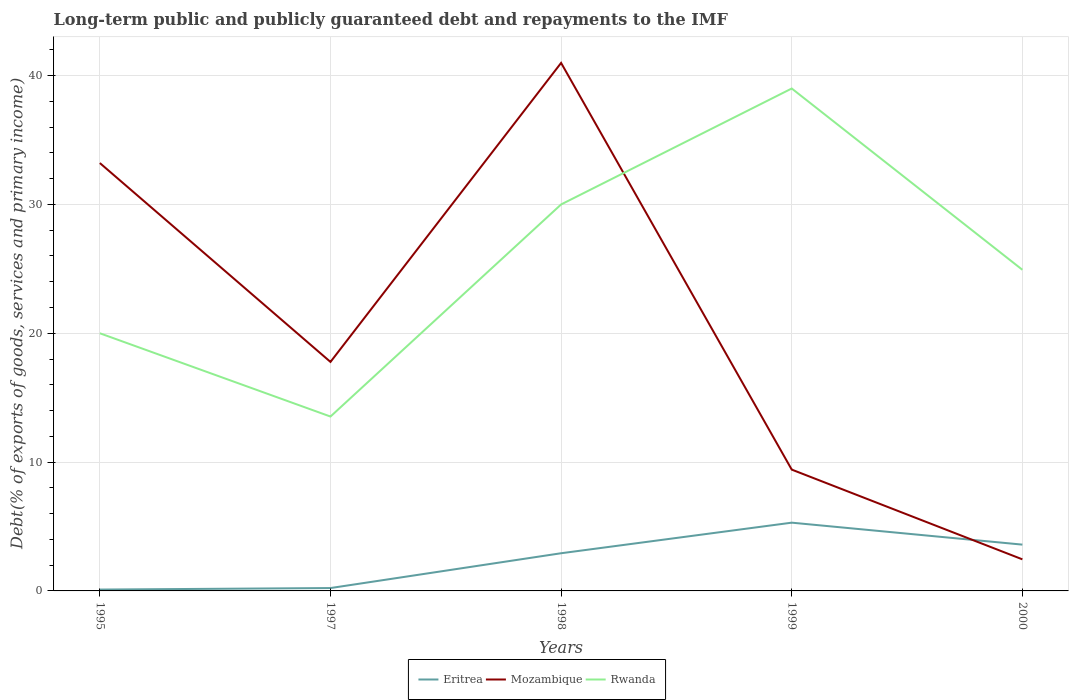How many different coloured lines are there?
Ensure brevity in your answer.  3. Does the line corresponding to Eritrea intersect with the line corresponding to Rwanda?
Keep it short and to the point. No. Across all years, what is the maximum debt and repayments in Rwanda?
Provide a short and direct response. 13.54. In which year was the debt and repayments in Eritrea maximum?
Your answer should be compact. 1995. What is the total debt and repayments in Eritrea in the graph?
Provide a short and direct response. -2.37. What is the difference between the highest and the second highest debt and repayments in Rwanda?
Give a very brief answer. 25.46. Is the debt and repayments in Eritrea strictly greater than the debt and repayments in Rwanda over the years?
Your answer should be very brief. Yes. How many years are there in the graph?
Make the answer very short. 5. What is the difference between two consecutive major ticks on the Y-axis?
Offer a very short reply. 10. Does the graph contain any zero values?
Provide a succinct answer. No. Does the graph contain grids?
Offer a terse response. Yes. Where does the legend appear in the graph?
Your answer should be very brief. Bottom center. How many legend labels are there?
Your answer should be very brief. 3. What is the title of the graph?
Make the answer very short. Long-term public and publicly guaranteed debt and repayments to the IMF. Does "Romania" appear as one of the legend labels in the graph?
Give a very brief answer. No. What is the label or title of the Y-axis?
Provide a succinct answer. Debt(% of exports of goods, services and primary income). What is the Debt(% of exports of goods, services and primary income) of Eritrea in 1995?
Your answer should be very brief. 0.11. What is the Debt(% of exports of goods, services and primary income) in Mozambique in 1995?
Keep it short and to the point. 33.21. What is the Debt(% of exports of goods, services and primary income) in Rwanda in 1995?
Your response must be concise. 20. What is the Debt(% of exports of goods, services and primary income) of Eritrea in 1997?
Make the answer very short. 0.22. What is the Debt(% of exports of goods, services and primary income) in Mozambique in 1997?
Offer a very short reply. 17.78. What is the Debt(% of exports of goods, services and primary income) of Rwanda in 1997?
Provide a short and direct response. 13.54. What is the Debt(% of exports of goods, services and primary income) of Eritrea in 1998?
Your answer should be very brief. 2.92. What is the Debt(% of exports of goods, services and primary income) in Mozambique in 1998?
Provide a short and direct response. 40.99. What is the Debt(% of exports of goods, services and primary income) of Eritrea in 1999?
Your answer should be compact. 5.3. What is the Debt(% of exports of goods, services and primary income) of Mozambique in 1999?
Provide a short and direct response. 9.42. What is the Debt(% of exports of goods, services and primary income) of Eritrea in 2000?
Provide a short and direct response. 3.59. What is the Debt(% of exports of goods, services and primary income) of Mozambique in 2000?
Your answer should be very brief. 2.45. What is the Debt(% of exports of goods, services and primary income) in Rwanda in 2000?
Make the answer very short. 24.93. Across all years, what is the maximum Debt(% of exports of goods, services and primary income) in Eritrea?
Provide a short and direct response. 5.3. Across all years, what is the maximum Debt(% of exports of goods, services and primary income) in Mozambique?
Your answer should be compact. 40.99. Across all years, what is the minimum Debt(% of exports of goods, services and primary income) in Eritrea?
Keep it short and to the point. 0.11. Across all years, what is the minimum Debt(% of exports of goods, services and primary income) in Mozambique?
Your answer should be compact. 2.45. Across all years, what is the minimum Debt(% of exports of goods, services and primary income) of Rwanda?
Offer a terse response. 13.54. What is the total Debt(% of exports of goods, services and primary income) of Eritrea in the graph?
Give a very brief answer. 12.14. What is the total Debt(% of exports of goods, services and primary income) of Mozambique in the graph?
Your answer should be very brief. 103.84. What is the total Debt(% of exports of goods, services and primary income) in Rwanda in the graph?
Your answer should be very brief. 127.47. What is the difference between the Debt(% of exports of goods, services and primary income) of Eritrea in 1995 and that in 1997?
Give a very brief answer. -0.12. What is the difference between the Debt(% of exports of goods, services and primary income) of Mozambique in 1995 and that in 1997?
Make the answer very short. 15.44. What is the difference between the Debt(% of exports of goods, services and primary income) of Rwanda in 1995 and that in 1997?
Give a very brief answer. 6.46. What is the difference between the Debt(% of exports of goods, services and primary income) of Eritrea in 1995 and that in 1998?
Provide a short and direct response. -2.82. What is the difference between the Debt(% of exports of goods, services and primary income) in Mozambique in 1995 and that in 1998?
Offer a very short reply. -7.77. What is the difference between the Debt(% of exports of goods, services and primary income) of Rwanda in 1995 and that in 1998?
Your answer should be very brief. -10. What is the difference between the Debt(% of exports of goods, services and primary income) in Eritrea in 1995 and that in 1999?
Keep it short and to the point. -5.19. What is the difference between the Debt(% of exports of goods, services and primary income) of Mozambique in 1995 and that in 1999?
Offer a very short reply. 23.8. What is the difference between the Debt(% of exports of goods, services and primary income) in Rwanda in 1995 and that in 1999?
Offer a terse response. -19. What is the difference between the Debt(% of exports of goods, services and primary income) of Eritrea in 1995 and that in 2000?
Provide a short and direct response. -3.49. What is the difference between the Debt(% of exports of goods, services and primary income) in Mozambique in 1995 and that in 2000?
Give a very brief answer. 30.76. What is the difference between the Debt(% of exports of goods, services and primary income) of Rwanda in 1995 and that in 2000?
Ensure brevity in your answer.  -4.93. What is the difference between the Debt(% of exports of goods, services and primary income) in Eritrea in 1997 and that in 1998?
Your response must be concise. -2.7. What is the difference between the Debt(% of exports of goods, services and primary income) in Mozambique in 1997 and that in 1998?
Offer a terse response. -23.21. What is the difference between the Debt(% of exports of goods, services and primary income) of Rwanda in 1997 and that in 1998?
Offer a terse response. -16.46. What is the difference between the Debt(% of exports of goods, services and primary income) of Eritrea in 1997 and that in 1999?
Provide a short and direct response. -5.08. What is the difference between the Debt(% of exports of goods, services and primary income) in Mozambique in 1997 and that in 1999?
Offer a terse response. 8.36. What is the difference between the Debt(% of exports of goods, services and primary income) in Rwanda in 1997 and that in 1999?
Make the answer very short. -25.46. What is the difference between the Debt(% of exports of goods, services and primary income) of Eritrea in 1997 and that in 2000?
Provide a succinct answer. -3.37. What is the difference between the Debt(% of exports of goods, services and primary income) in Mozambique in 1997 and that in 2000?
Your answer should be very brief. 15.32. What is the difference between the Debt(% of exports of goods, services and primary income) of Rwanda in 1997 and that in 2000?
Make the answer very short. -11.39. What is the difference between the Debt(% of exports of goods, services and primary income) in Eritrea in 1998 and that in 1999?
Make the answer very short. -2.37. What is the difference between the Debt(% of exports of goods, services and primary income) in Mozambique in 1998 and that in 1999?
Make the answer very short. 31.57. What is the difference between the Debt(% of exports of goods, services and primary income) in Rwanda in 1998 and that in 1999?
Your answer should be very brief. -9. What is the difference between the Debt(% of exports of goods, services and primary income) in Eritrea in 1998 and that in 2000?
Your response must be concise. -0.67. What is the difference between the Debt(% of exports of goods, services and primary income) of Mozambique in 1998 and that in 2000?
Your answer should be very brief. 38.53. What is the difference between the Debt(% of exports of goods, services and primary income) in Rwanda in 1998 and that in 2000?
Provide a short and direct response. 5.07. What is the difference between the Debt(% of exports of goods, services and primary income) of Eritrea in 1999 and that in 2000?
Your answer should be compact. 1.7. What is the difference between the Debt(% of exports of goods, services and primary income) of Mozambique in 1999 and that in 2000?
Provide a short and direct response. 6.96. What is the difference between the Debt(% of exports of goods, services and primary income) of Rwanda in 1999 and that in 2000?
Keep it short and to the point. 14.07. What is the difference between the Debt(% of exports of goods, services and primary income) in Eritrea in 1995 and the Debt(% of exports of goods, services and primary income) in Mozambique in 1997?
Provide a succinct answer. -17.67. What is the difference between the Debt(% of exports of goods, services and primary income) in Eritrea in 1995 and the Debt(% of exports of goods, services and primary income) in Rwanda in 1997?
Ensure brevity in your answer.  -13.43. What is the difference between the Debt(% of exports of goods, services and primary income) in Mozambique in 1995 and the Debt(% of exports of goods, services and primary income) in Rwanda in 1997?
Make the answer very short. 19.68. What is the difference between the Debt(% of exports of goods, services and primary income) of Eritrea in 1995 and the Debt(% of exports of goods, services and primary income) of Mozambique in 1998?
Make the answer very short. -40.88. What is the difference between the Debt(% of exports of goods, services and primary income) in Eritrea in 1995 and the Debt(% of exports of goods, services and primary income) in Rwanda in 1998?
Provide a short and direct response. -29.89. What is the difference between the Debt(% of exports of goods, services and primary income) in Mozambique in 1995 and the Debt(% of exports of goods, services and primary income) in Rwanda in 1998?
Keep it short and to the point. 3.21. What is the difference between the Debt(% of exports of goods, services and primary income) in Eritrea in 1995 and the Debt(% of exports of goods, services and primary income) in Mozambique in 1999?
Provide a succinct answer. -9.31. What is the difference between the Debt(% of exports of goods, services and primary income) of Eritrea in 1995 and the Debt(% of exports of goods, services and primary income) of Rwanda in 1999?
Make the answer very short. -38.89. What is the difference between the Debt(% of exports of goods, services and primary income) in Mozambique in 1995 and the Debt(% of exports of goods, services and primary income) in Rwanda in 1999?
Give a very brief answer. -5.79. What is the difference between the Debt(% of exports of goods, services and primary income) in Eritrea in 1995 and the Debt(% of exports of goods, services and primary income) in Mozambique in 2000?
Give a very brief answer. -2.35. What is the difference between the Debt(% of exports of goods, services and primary income) in Eritrea in 1995 and the Debt(% of exports of goods, services and primary income) in Rwanda in 2000?
Make the answer very short. -24.82. What is the difference between the Debt(% of exports of goods, services and primary income) in Mozambique in 1995 and the Debt(% of exports of goods, services and primary income) in Rwanda in 2000?
Provide a short and direct response. 8.28. What is the difference between the Debt(% of exports of goods, services and primary income) of Eritrea in 1997 and the Debt(% of exports of goods, services and primary income) of Mozambique in 1998?
Make the answer very short. -40.76. What is the difference between the Debt(% of exports of goods, services and primary income) of Eritrea in 1997 and the Debt(% of exports of goods, services and primary income) of Rwanda in 1998?
Your response must be concise. -29.78. What is the difference between the Debt(% of exports of goods, services and primary income) in Mozambique in 1997 and the Debt(% of exports of goods, services and primary income) in Rwanda in 1998?
Keep it short and to the point. -12.22. What is the difference between the Debt(% of exports of goods, services and primary income) in Eritrea in 1997 and the Debt(% of exports of goods, services and primary income) in Mozambique in 1999?
Provide a succinct answer. -9.19. What is the difference between the Debt(% of exports of goods, services and primary income) of Eritrea in 1997 and the Debt(% of exports of goods, services and primary income) of Rwanda in 1999?
Make the answer very short. -38.78. What is the difference between the Debt(% of exports of goods, services and primary income) of Mozambique in 1997 and the Debt(% of exports of goods, services and primary income) of Rwanda in 1999?
Offer a very short reply. -21.22. What is the difference between the Debt(% of exports of goods, services and primary income) in Eritrea in 1997 and the Debt(% of exports of goods, services and primary income) in Mozambique in 2000?
Provide a short and direct response. -2.23. What is the difference between the Debt(% of exports of goods, services and primary income) of Eritrea in 1997 and the Debt(% of exports of goods, services and primary income) of Rwanda in 2000?
Your response must be concise. -24.71. What is the difference between the Debt(% of exports of goods, services and primary income) in Mozambique in 1997 and the Debt(% of exports of goods, services and primary income) in Rwanda in 2000?
Give a very brief answer. -7.15. What is the difference between the Debt(% of exports of goods, services and primary income) of Eritrea in 1998 and the Debt(% of exports of goods, services and primary income) of Mozambique in 1999?
Provide a short and direct response. -6.49. What is the difference between the Debt(% of exports of goods, services and primary income) of Eritrea in 1998 and the Debt(% of exports of goods, services and primary income) of Rwanda in 1999?
Provide a succinct answer. -36.08. What is the difference between the Debt(% of exports of goods, services and primary income) in Mozambique in 1998 and the Debt(% of exports of goods, services and primary income) in Rwanda in 1999?
Offer a very short reply. 1.99. What is the difference between the Debt(% of exports of goods, services and primary income) of Eritrea in 1998 and the Debt(% of exports of goods, services and primary income) of Mozambique in 2000?
Provide a succinct answer. 0.47. What is the difference between the Debt(% of exports of goods, services and primary income) of Eritrea in 1998 and the Debt(% of exports of goods, services and primary income) of Rwanda in 2000?
Ensure brevity in your answer.  -22. What is the difference between the Debt(% of exports of goods, services and primary income) of Mozambique in 1998 and the Debt(% of exports of goods, services and primary income) of Rwanda in 2000?
Keep it short and to the point. 16.06. What is the difference between the Debt(% of exports of goods, services and primary income) in Eritrea in 1999 and the Debt(% of exports of goods, services and primary income) in Mozambique in 2000?
Ensure brevity in your answer.  2.85. What is the difference between the Debt(% of exports of goods, services and primary income) of Eritrea in 1999 and the Debt(% of exports of goods, services and primary income) of Rwanda in 2000?
Ensure brevity in your answer.  -19.63. What is the difference between the Debt(% of exports of goods, services and primary income) of Mozambique in 1999 and the Debt(% of exports of goods, services and primary income) of Rwanda in 2000?
Your response must be concise. -15.51. What is the average Debt(% of exports of goods, services and primary income) in Eritrea per year?
Your answer should be very brief. 2.43. What is the average Debt(% of exports of goods, services and primary income) in Mozambique per year?
Your answer should be very brief. 20.77. What is the average Debt(% of exports of goods, services and primary income) in Rwanda per year?
Keep it short and to the point. 25.49. In the year 1995, what is the difference between the Debt(% of exports of goods, services and primary income) of Eritrea and Debt(% of exports of goods, services and primary income) of Mozambique?
Make the answer very short. -33.11. In the year 1995, what is the difference between the Debt(% of exports of goods, services and primary income) of Eritrea and Debt(% of exports of goods, services and primary income) of Rwanda?
Offer a terse response. -19.9. In the year 1995, what is the difference between the Debt(% of exports of goods, services and primary income) of Mozambique and Debt(% of exports of goods, services and primary income) of Rwanda?
Give a very brief answer. 13.21. In the year 1997, what is the difference between the Debt(% of exports of goods, services and primary income) in Eritrea and Debt(% of exports of goods, services and primary income) in Mozambique?
Give a very brief answer. -17.55. In the year 1997, what is the difference between the Debt(% of exports of goods, services and primary income) of Eritrea and Debt(% of exports of goods, services and primary income) of Rwanda?
Your response must be concise. -13.31. In the year 1997, what is the difference between the Debt(% of exports of goods, services and primary income) of Mozambique and Debt(% of exports of goods, services and primary income) of Rwanda?
Make the answer very short. 4.24. In the year 1998, what is the difference between the Debt(% of exports of goods, services and primary income) in Eritrea and Debt(% of exports of goods, services and primary income) in Mozambique?
Provide a short and direct response. -38.06. In the year 1998, what is the difference between the Debt(% of exports of goods, services and primary income) of Eritrea and Debt(% of exports of goods, services and primary income) of Rwanda?
Offer a very short reply. -27.08. In the year 1998, what is the difference between the Debt(% of exports of goods, services and primary income) of Mozambique and Debt(% of exports of goods, services and primary income) of Rwanda?
Your response must be concise. 10.99. In the year 1999, what is the difference between the Debt(% of exports of goods, services and primary income) of Eritrea and Debt(% of exports of goods, services and primary income) of Mozambique?
Keep it short and to the point. -4.12. In the year 1999, what is the difference between the Debt(% of exports of goods, services and primary income) in Eritrea and Debt(% of exports of goods, services and primary income) in Rwanda?
Give a very brief answer. -33.7. In the year 1999, what is the difference between the Debt(% of exports of goods, services and primary income) in Mozambique and Debt(% of exports of goods, services and primary income) in Rwanda?
Offer a very short reply. -29.58. In the year 2000, what is the difference between the Debt(% of exports of goods, services and primary income) in Eritrea and Debt(% of exports of goods, services and primary income) in Mozambique?
Ensure brevity in your answer.  1.14. In the year 2000, what is the difference between the Debt(% of exports of goods, services and primary income) in Eritrea and Debt(% of exports of goods, services and primary income) in Rwanda?
Provide a succinct answer. -21.34. In the year 2000, what is the difference between the Debt(% of exports of goods, services and primary income) of Mozambique and Debt(% of exports of goods, services and primary income) of Rwanda?
Your answer should be very brief. -22.48. What is the ratio of the Debt(% of exports of goods, services and primary income) in Eritrea in 1995 to that in 1997?
Make the answer very short. 0.47. What is the ratio of the Debt(% of exports of goods, services and primary income) in Mozambique in 1995 to that in 1997?
Your response must be concise. 1.87. What is the ratio of the Debt(% of exports of goods, services and primary income) of Rwanda in 1995 to that in 1997?
Ensure brevity in your answer.  1.48. What is the ratio of the Debt(% of exports of goods, services and primary income) in Eritrea in 1995 to that in 1998?
Provide a succinct answer. 0.04. What is the ratio of the Debt(% of exports of goods, services and primary income) of Mozambique in 1995 to that in 1998?
Offer a very short reply. 0.81. What is the ratio of the Debt(% of exports of goods, services and primary income) in Rwanda in 1995 to that in 1998?
Give a very brief answer. 0.67. What is the ratio of the Debt(% of exports of goods, services and primary income) of Eritrea in 1995 to that in 1999?
Your answer should be compact. 0.02. What is the ratio of the Debt(% of exports of goods, services and primary income) in Mozambique in 1995 to that in 1999?
Provide a short and direct response. 3.53. What is the ratio of the Debt(% of exports of goods, services and primary income) in Rwanda in 1995 to that in 1999?
Provide a succinct answer. 0.51. What is the ratio of the Debt(% of exports of goods, services and primary income) in Eritrea in 1995 to that in 2000?
Offer a terse response. 0.03. What is the ratio of the Debt(% of exports of goods, services and primary income) of Mozambique in 1995 to that in 2000?
Make the answer very short. 13.55. What is the ratio of the Debt(% of exports of goods, services and primary income) in Rwanda in 1995 to that in 2000?
Ensure brevity in your answer.  0.8. What is the ratio of the Debt(% of exports of goods, services and primary income) in Eritrea in 1997 to that in 1998?
Give a very brief answer. 0.08. What is the ratio of the Debt(% of exports of goods, services and primary income) of Mozambique in 1997 to that in 1998?
Keep it short and to the point. 0.43. What is the ratio of the Debt(% of exports of goods, services and primary income) in Rwanda in 1997 to that in 1998?
Your answer should be very brief. 0.45. What is the ratio of the Debt(% of exports of goods, services and primary income) of Eritrea in 1997 to that in 1999?
Ensure brevity in your answer.  0.04. What is the ratio of the Debt(% of exports of goods, services and primary income) of Mozambique in 1997 to that in 1999?
Keep it short and to the point. 1.89. What is the ratio of the Debt(% of exports of goods, services and primary income) in Rwanda in 1997 to that in 1999?
Your answer should be very brief. 0.35. What is the ratio of the Debt(% of exports of goods, services and primary income) of Eritrea in 1997 to that in 2000?
Your answer should be very brief. 0.06. What is the ratio of the Debt(% of exports of goods, services and primary income) in Mozambique in 1997 to that in 2000?
Offer a terse response. 7.25. What is the ratio of the Debt(% of exports of goods, services and primary income) in Rwanda in 1997 to that in 2000?
Your response must be concise. 0.54. What is the ratio of the Debt(% of exports of goods, services and primary income) of Eritrea in 1998 to that in 1999?
Ensure brevity in your answer.  0.55. What is the ratio of the Debt(% of exports of goods, services and primary income) in Mozambique in 1998 to that in 1999?
Keep it short and to the point. 4.35. What is the ratio of the Debt(% of exports of goods, services and primary income) of Rwanda in 1998 to that in 1999?
Offer a terse response. 0.77. What is the ratio of the Debt(% of exports of goods, services and primary income) of Eritrea in 1998 to that in 2000?
Your answer should be compact. 0.81. What is the ratio of the Debt(% of exports of goods, services and primary income) of Mozambique in 1998 to that in 2000?
Provide a short and direct response. 16.72. What is the ratio of the Debt(% of exports of goods, services and primary income) in Rwanda in 1998 to that in 2000?
Your response must be concise. 1.2. What is the ratio of the Debt(% of exports of goods, services and primary income) of Eritrea in 1999 to that in 2000?
Your response must be concise. 1.47. What is the ratio of the Debt(% of exports of goods, services and primary income) of Mozambique in 1999 to that in 2000?
Your answer should be very brief. 3.84. What is the ratio of the Debt(% of exports of goods, services and primary income) in Rwanda in 1999 to that in 2000?
Your response must be concise. 1.56. What is the difference between the highest and the second highest Debt(% of exports of goods, services and primary income) in Eritrea?
Your answer should be compact. 1.7. What is the difference between the highest and the second highest Debt(% of exports of goods, services and primary income) of Mozambique?
Provide a short and direct response. 7.77. What is the difference between the highest and the lowest Debt(% of exports of goods, services and primary income) in Eritrea?
Provide a succinct answer. 5.19. What is the difference between the highest and the lowest Debt(% of exports of goods, services and primary income) of Mozambique?
Provide a short and direct response. 38.53. What is the difference between the highest and the lowest Debt(% of exports of goods, services and primary income) in Rwanda?
Your answer should be very brief. 25.46. 